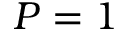Convert formula to latex. <formula><loc_0><loc_0><loc_500><loc_500>P = 1</formula> 